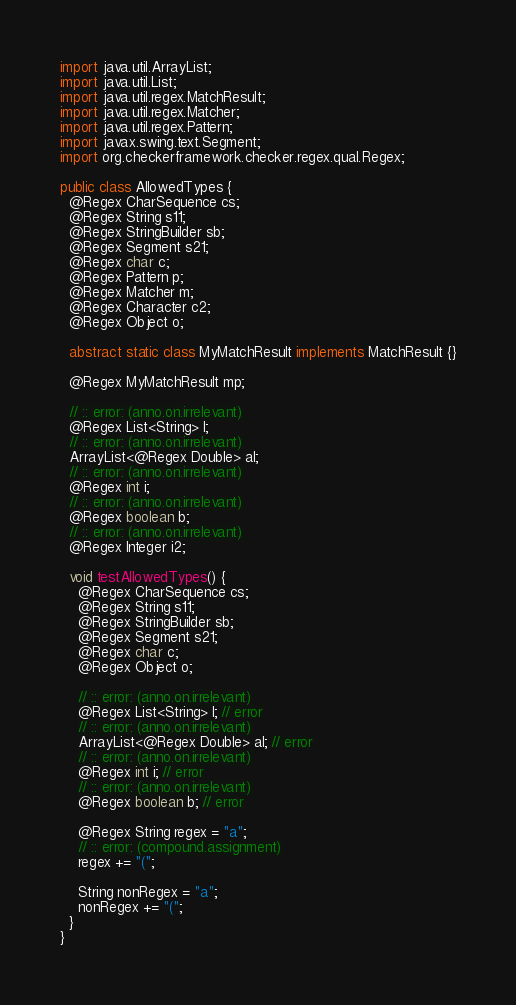<code> <loc_0><loc_0><loc_500><loc_500><_Java_>import java.util.ArrayList;
import java.util.List;
import java.util.regex.MatchResult;
import java.util.regex.Matcher;
import java.util.regex.Pattern;
import javax.swing.text.Segment;
import org.checkerframework.checker.regex.qual.Regex;

public class AllowedTypes {
  @Regex CharSequence cs;
  @Regex String s11;
  @Regex StringBuilder sb;
  @Regex Segment s21;
  @Regex char c;
  @Regex Pattern p;
  @Regex Matcher m;
  @Regex Character c2;
  @Regex Object o;

  abstract static class MyMatchResult implements MatchResult {}

  @Regex MyMatchResult mp;

  // :: error: (anno.on.irrelevant)
  @Regex List<String> l;
  // :: error: (anno.on.irrelevant)
  ArrayList<@Regex Double> al;
  // :: error: (anno.on.irrelevant)
  @Regex int i;
  // :: error: (anno.on.irrelevant)
  @Regex boolean b;
  // :: error: (anno.on.irrelevant)
  @Regex Integer i2;

  void testAllowedTypes() {
    @Regex CharSequence cs;
    @Regex String s11;
    @Regex StringBuilder sb;
    @Regex Segment s21;
    @Regex char c;
    @Regex Object o;

    // :: error: (anno.on.irrelevant)
    @Regex List<String> l; // error
    // :: error: (anno.on.irrelevant)
    ArrayList<@Regex Double> al; // error
    // :: error: (anno.on.irrelevant)
    @Regex int i; // error
    // :: error: (anno.on.irrelevant)
    @Regex boolean b; // error

    @Regex String regex = "a";
    // :: error: (compound.assignment)
    regex += "(";

    String nonRegex = "a";
    nonRegex += "(";
  }
}
</code> 